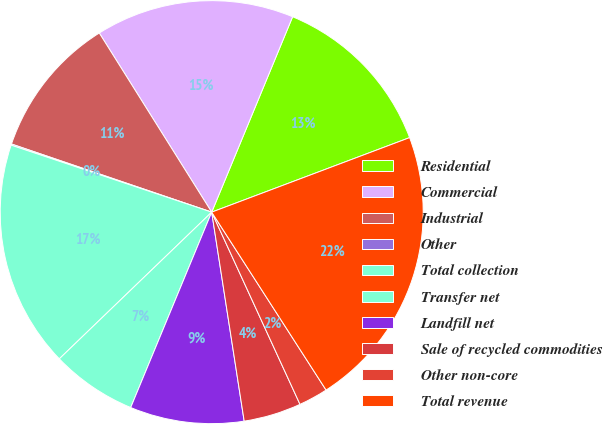<chart> <loc_0><loc_0><loc_500><loc_500><pie_chart><fcel>Residential<fcel>Commercial<fcel>Industrial<fcel>Other<fcel>Total collection<fcel>Transfer net<fcel>Landfill net<fcel>Sale of recycled commodities<fcel>Other non-core<fcel>Total revenue<nl><fcel>13.02%<fcel>15.17%<fcel>10.86%<fcel>0.09%<fcel>17.33%<fcel>6.55%<fcel>8.71%<fcel>4.4%<fcel>2.24%<fcel>21.64%<nl></chart> 